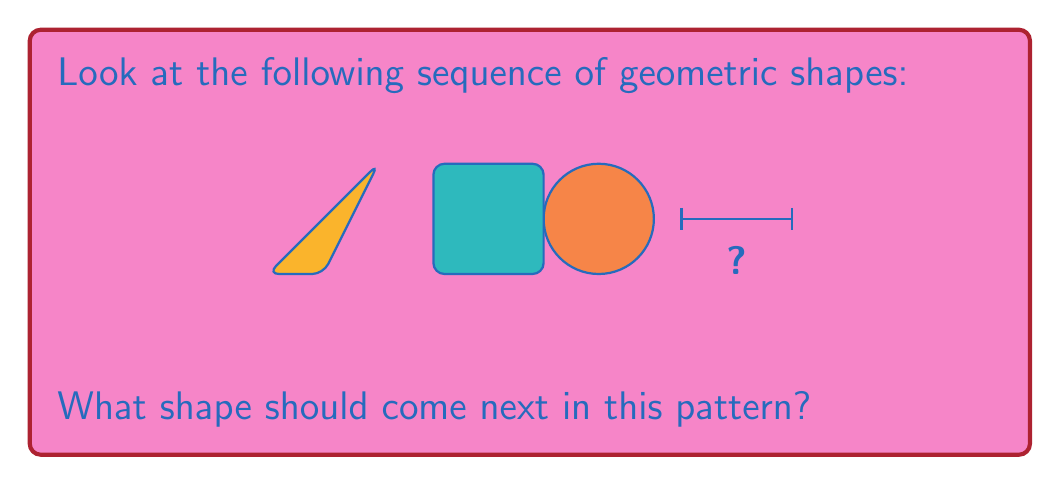Could you help me with this problem? To solve this problem, we need to analyze the pattern of shapes presented:

1. The sequence starts with a circle.
2. The second shape is a square.
3. The third shape is a triangle.

To determine the next shape, we need to identify the rule that governs this sequence. In this case, we can observe that the number of sides in each shape is decreasing:

- Circle: Infinite sides (or can be thought of as a many-sided polygon)
- Square: 4 sides
- Triangle: 3 sides

Following this pattern, the next shape should have 2 sides.

The only two-dimensional shape that can be formed with 2 straight sides is a line segment.

Therefore, the next shape in the sequence should be a line segment.

This type of pattern recognition is crucial for developing spatial intelligence and mathematical reasoning skills, which are important for building a strong foundation in mathematics.
Answer: Line segment 